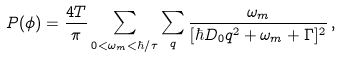<formula> <loc_0><loc_0><loc_500><loc_500>P ( \phi ) = \frac { 4 T } { \pi } \sum _ { 0 < \omega _ { m } < \hbar { / } \tau } \sum _ { q } \frac { \omega _ { m } } { [ \hbar { D } _ { 0 } { q } ^ { 2 } + \omega _ { m } + \Gamma ] ^ { 2 } } \, ,</formula> 